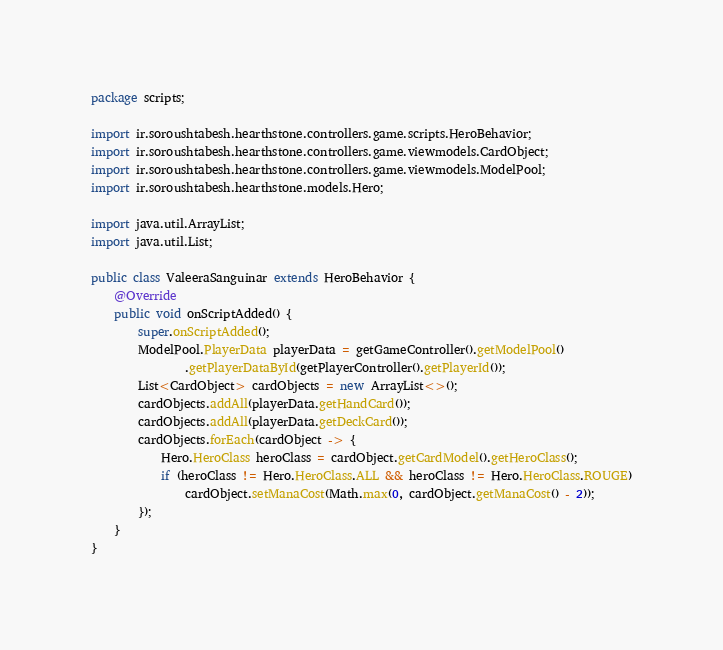Convert code to text. <code><loc_0><loc_0><loc_500><loc_500><_Java_>package scripts;

import ir.soroushtabesh.hearthstone.controllers.game.scripts.HeroBehavior;
import ir.soroushtabesh.hearthstone.controllers.game.viewmodels.CardObject;
import ir.soroushtabesh.hearthstone.controllers.game.viewmodels.ModelPool;
import ir.soroushtabesh.hearthstone.models.Hero;

import java.util.ArrayList;
import java.util.List;

public class ValeeraSanguinar extends HeroBehavior {
    @Override
    public void onScriptAdded() {
        super.onScriptAdded();
        ModelPool.PlayerData playerData = getGameController().getModelPool()
                .getPlayerDataById(getPlayerController().getPlayerId());
        List<CardObject> cardObjects = new ArrayList<>();
        cardObjects.addAll(playerData.getHandCard());
        cardObjects.addAll(playerData.getDeckCard());
        cardObjects.forEach(cardObject -> {
            Hero.HeroClass heroClass = cardObject.getCardModel().getHeroClass();
            if (heroClass != Hero.HeroClass.ALL && heroClass != Hero.HeroClass.ROUGE)
                cardObject.setManaCost(Math.max(0, cardObject.getManaCost() - 2));
        });
    }
}
</code> 